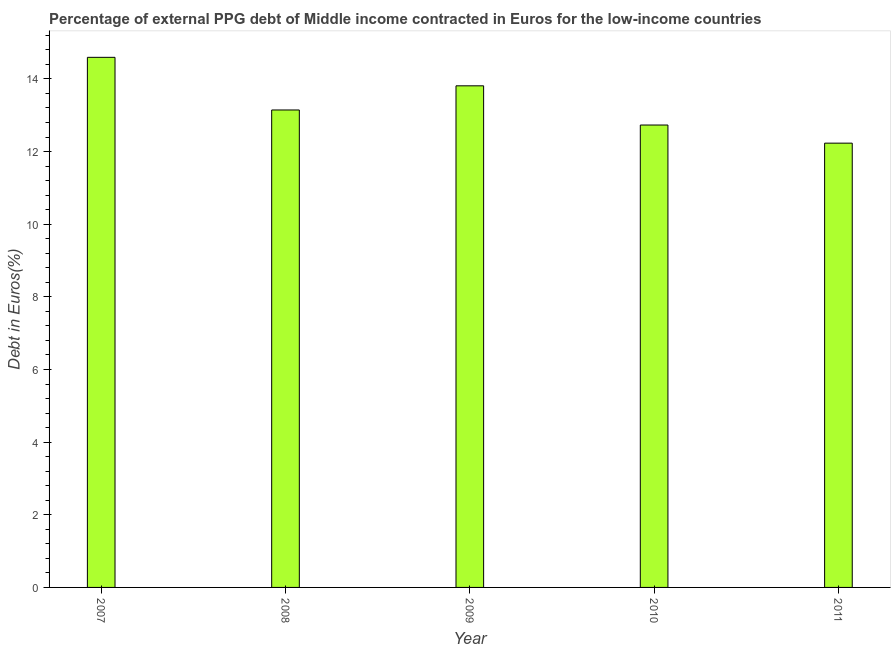Does the graph contain any zero values?
Make the answer very short. No. Does the graph contain grids?
Provide a succinct answer. No. What is the title of the graph?
Provide a short and direct response. Percentage of external PPG debt of Middle income contracted in Euros for the low-income countries. What is the label or title of the Y-axis?
Provide a succinct answer. Debt in Euros(%). What is the currency composition of ppg debt in 2008?
Offer a very short reply. 13.14. Across all years, what is the maximum currency composition of ppg debt?
Your answer should be very brief. 14.59. Across all years, what is the minimum currency composition of ppg debt?
Give a very brief answer. 12.23. In which year was the currency composition of ppg debt minimum?
Provide a short and direct response. 2011. What is the sum of the currency composition of ppg debt?
Offer a very short reply. 66.51. What is the difference between the currency composition of ppg debt in 2008 and 2011?
Provide a short and direct response. 0.91. What is the average currency composition of ppg debt per year?
Offer a terse response. 13.3. What is the median currency composition of ppg debt?
Provide a short and direct response. 13.14. In how many years, is the currency composition of ppg debt greater than 5.2 %?
Ensure brevity in your answer.  5. What is the ratio of the currency composition of ppg debt in 2007 to that in 2011?
Your response must be concise. 1.19. Is the currency composition of ppg debt in 2008 less than that in 2010?
Make the answer very short. No. What is the difference between the highest and the second highest currency composition of ppg debt?
Your response must be concise. 0.78. What is the difference between the highest and the lowest currency composition of ppg debt?
Your answer should be compact. 2.36. How many bars are there?
Your answer should be very brief. 5. What is the difference between two consecutive major ticks on the Y-axis?
Your answer should be compact. 2. What is the Debt in Euros(%) of 2007?
Provide a succinct answer. 14.59. What is the Debt in Euros(%) of 2008?
Ensure brevity in your answer.  13.14. What is the Debt in Euros(%) of 2009?
Make the answer very short. 13.81. What is the Debt in Euros(%) of 2010?
Your answer should be very brief. 12.73. What is the Debt in Euros(%) in 2011?
Ensure brevity in your answer.  12.23. What is the difference between the Debt in Euros(%) in 2007 and 2008?
Your answer should be very brief. 1.45. What is the difference between the Debt in Euros(%) in 2007 and 2009?
Keep it short and to the point. 0.78. What is the difference between the Debt in Euros(%) in 2007 and 2010?
Offer a terse response. 1.86. What is the difference between the Debt in Euros(%) in 2007 and 2011?
Your answer should be compact. 2.36. What is the difference between the Debt in Euros(%) in 2008 and 2009?
Offer a terse response. -0.67. What is the difference between the Debt in Euros(%) in 2008 and 2010?
Ensure brevity in your answer.  0.41. What is the difference between the Debt in Euros(%) in 2008 and 2011?
Your answer should be very brief. 0.91. What is the difference between the Debt in Euros(%) in 2009 and 2010?
Offer a terse response. 1.08. What is the difference between the Debt in Euros(%) in 2009 and 2011?
Your response must be concise. 1.58. What is the difference between the Debt in Euros(%) in 2010 and 2011?
Give a very brief answer. 0.5. What is the ratio of the Debt in Euros(%) in 2007 to that in 2008?
Your answer should be compact. 1.11. What is the ratio of the Debt in Euros(%) in 2007 to that in 2009?
Your response must be concise. 1.06. What is the ratio of the Debt in Euros(%) in 2007 to that in 2010?
Offer a terse response. 1.15. What is the ratio of the Debt in Euros(%) in 2007 to that in 2011?
Your answer should be very brief. 1.19. What is the ratio of the Debt in Euros(%) in 2008 to that in 2010?
Give a very brief answer. 1.03. What is the ratio of the Debt in Euros(%) in 2008 to that in 2011?
Offer a terse response. 1.07. What is the ratio of the Debt in Euros(%) in 2009 to that in 2010?
Your response must be concise. 1.08. What is the ratio of the Debt in Euros(%) in 2009 to that in 2011?
Provide a short and direct response. 1.13. What is the ratio of the Debt in Euros(%) in 2010 to that in 2011?
Provide a succinct answer. 1.04. 